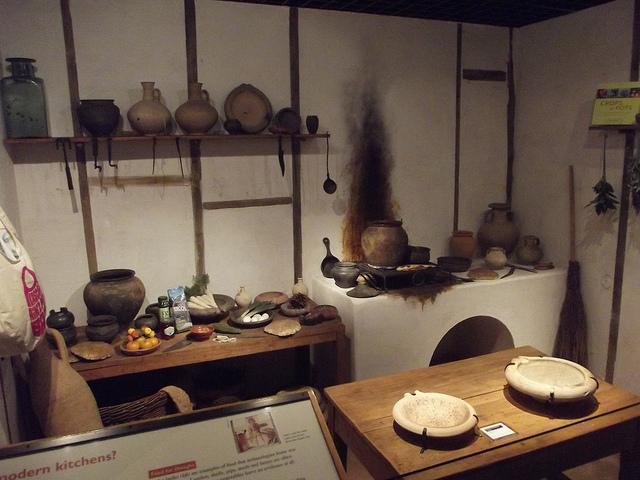In what type building is this located?
Indicate the correct response by choosing from the four available options to answer the question.
Options: Gym, museum, basketball hall, residence. Museum. 